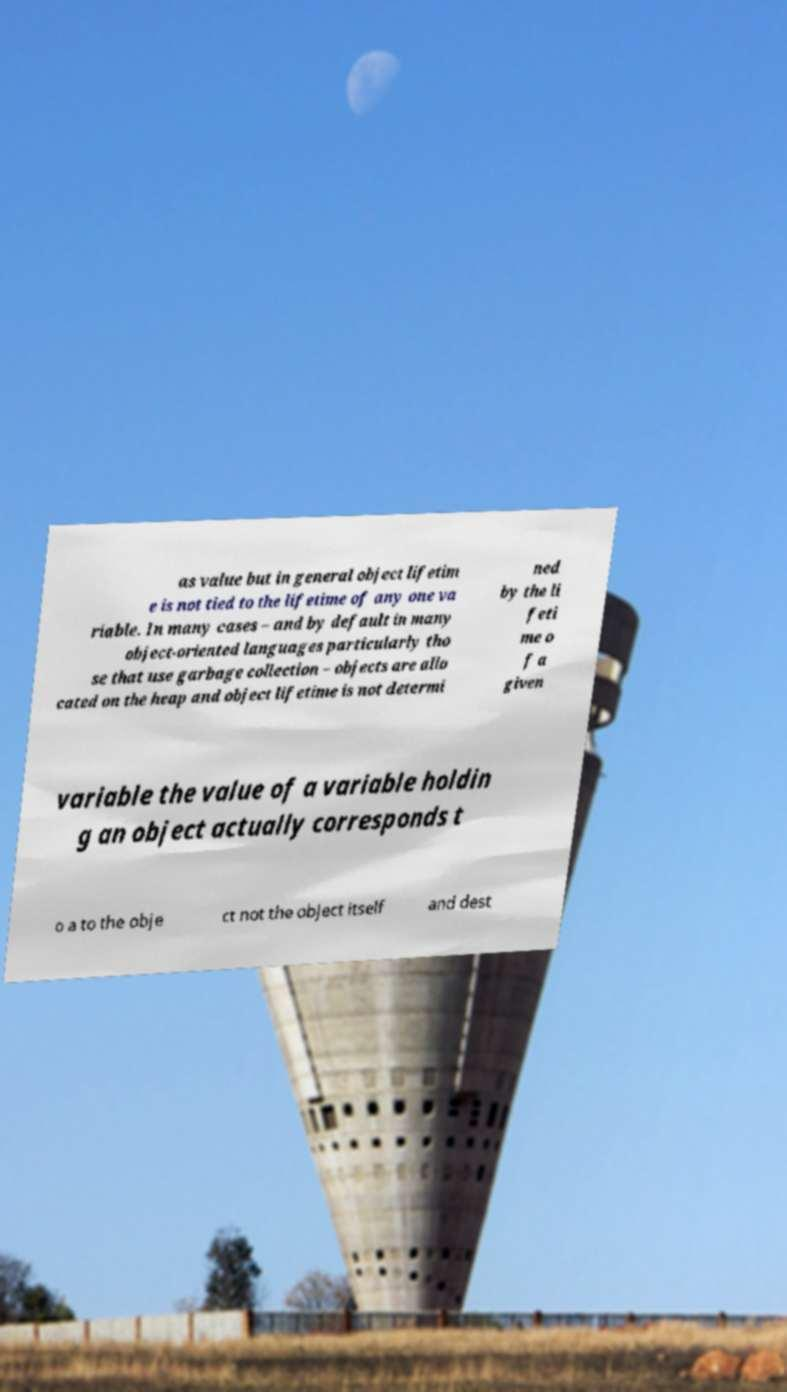What messages or text are displayed in this image? I need them in a readable, typed format. as value but in general object lifetim e is not tied to the lifetime of any one va riable. In many cases – and by default in many object-oriented languages particularly tho se that use garbage collection – objects are allo cated on the heap and object lifetime is not determi ned by the li feti me o f a given variable the value of a variable holdin g an object actually corresponds t o a to the obje ct not the object itself and dest 